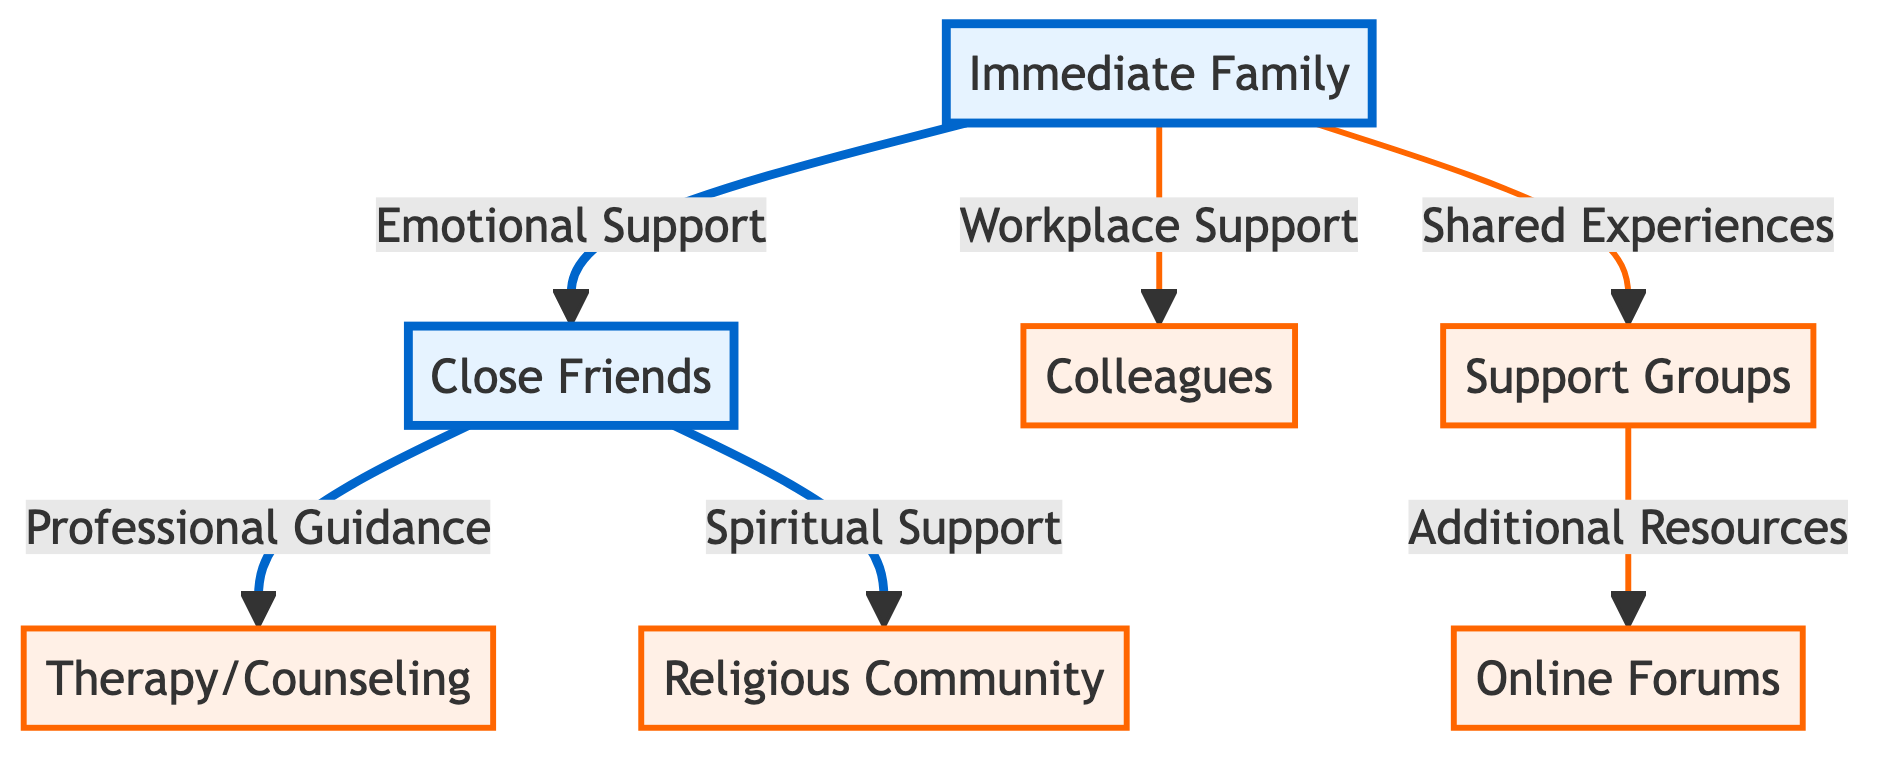What are the types of immediate family connections shown in the diagram? The diagram identifies three types of connections stemming from "Immediate Family": Emotional Support, Workplace Support, and Shared Experiences.
Answer: Emotional Support, Workplace Support, Shared Experiences Which node is connected to the "Close Friends"? "Close Friends" is connected to "Therapy/Counseling" through Professional Guidance and "Religious Community" through Spiritual Support.
Answer: Therapy/Counseling, Religious Community How many support types are linked to "Immediate Family"? The diagram shows three connections from "Immediate Family": to "Close Friends," "Colleagues," and "Support Groups," indicating three support types.
Answer: 3 What resource is connected to "Support Groups"? "Support Groups" leads to "Online Forums" as an Additional Resource.
Answer: Online Forums Which connection provides Spiritual Support? The connection providing Spiritual Support is between "Close Friends" and "Religious Community."
Answer: Religious Community What is the relationship type between "Immediate Family" and "Colleagues"? The relationship type between "Immediate Family" and "Colleagues" is defined as Workplace Support.
Answer: Workplace Support Which node has the least number of connections? "Online Forums" is the only node directly connected from "Support Groups," showing it has the least number of connections.
Answer: Online Forums How many nodes represent secondary support systems in total? There are five secondary support system nodes: "Colleagues," "Support Groups," "Therapy/Counseling," "Religious Community," and "Online Forums."
Answer: 5 What type of support do "Close Friends" provide that relates to professional guidance? "Close Friends" provide Professional Guidance through "Therapy/Counseling."
Answer: Therapy/Counseling 